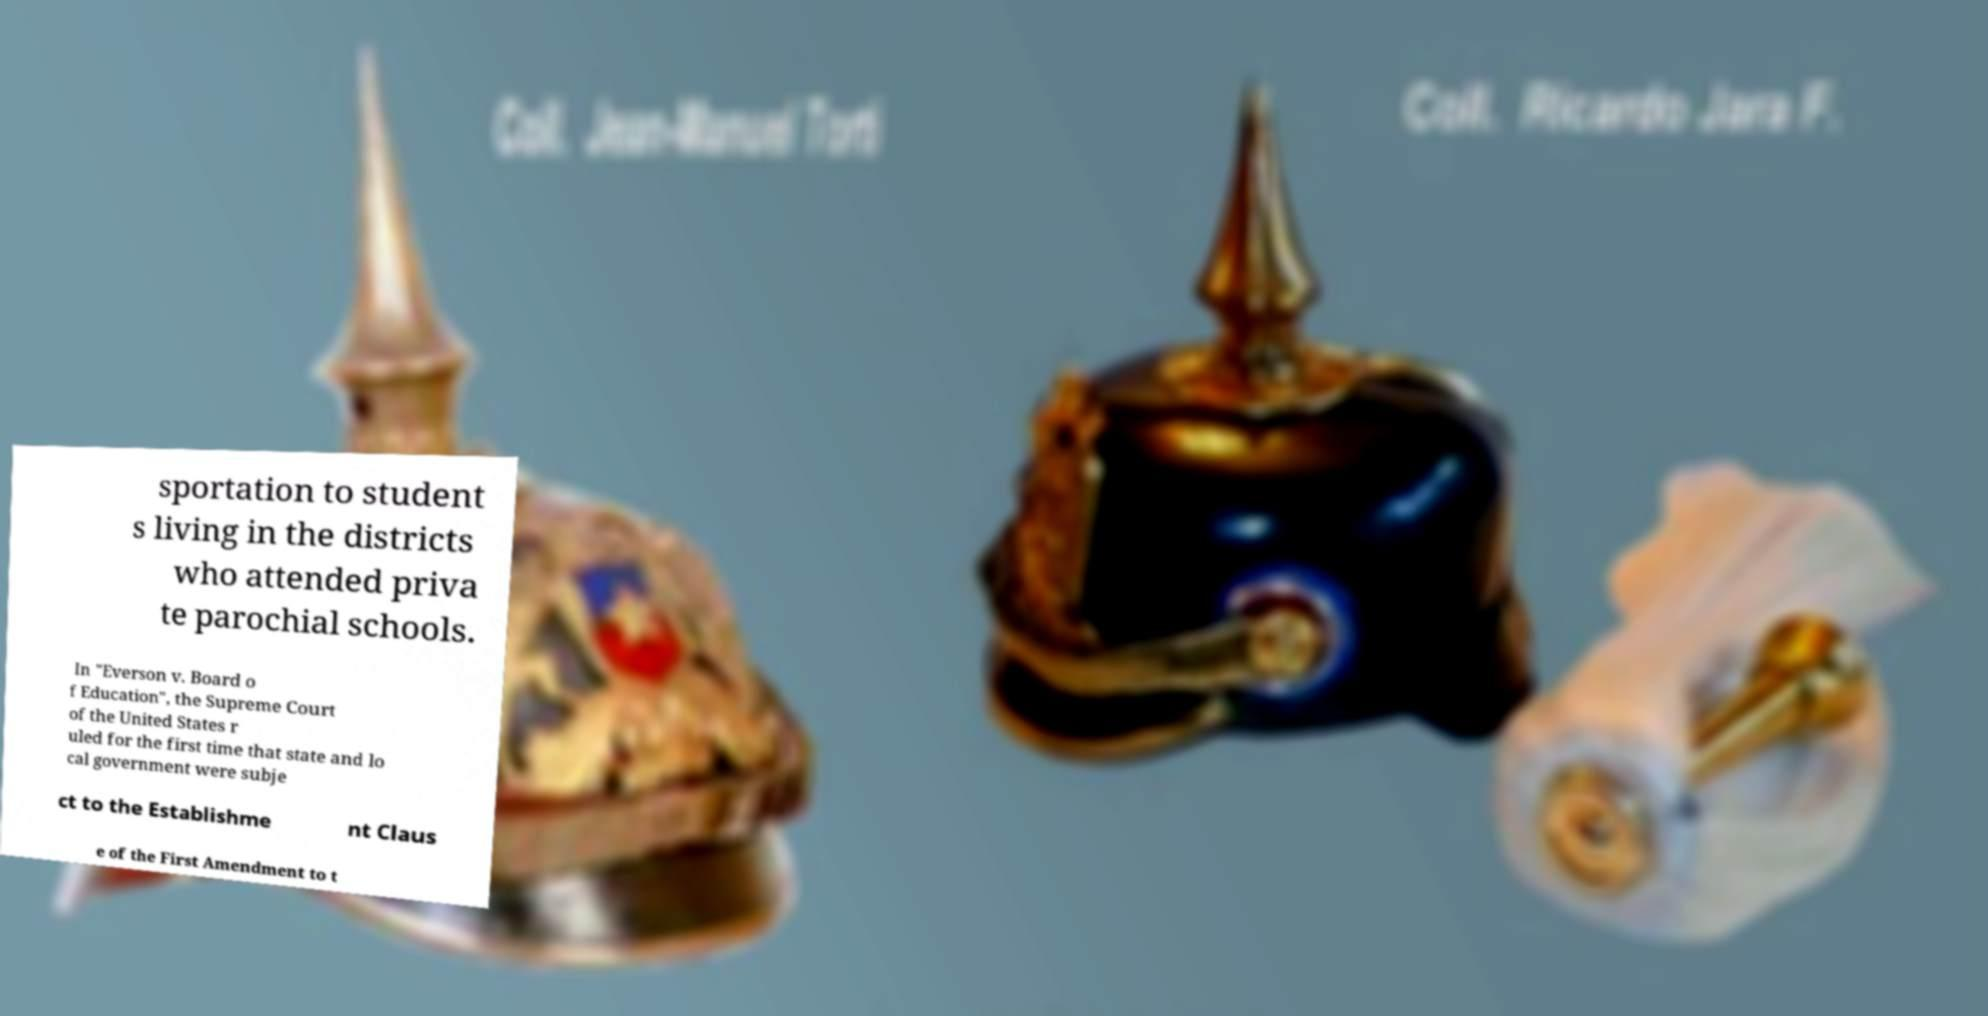I need the written content from this picture converted into text. Can you do that? sportation to student s living in the districts who attended priva te parochial schools. In "Everson v. Board o f Education", the Supreme Court of the United States r uled for the first time that state and lo cal government were subje ct to the Establishme nt Claus e of the First Amendment to t 